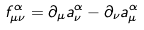<formula> <loc_0><loc_0><loc_500><loc_500>f _ { \mu \nu } ^ { \alpha } = \partial _ { \mu } a ^ { \alpha } _ { \nu } - \partial _ { \nu } a ^ { \alpha } _ { \mu }</formula> 